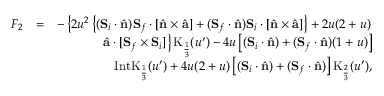<formula> <loc_0><loc_0><loc_500><loc_500>\begin{array} { r l r } { F _ { 2 } } & { = } & { - \left \{ 2 u ^ { 2 } \left \{ ( { S } _ { i } \cdot \hat { n } ) { S } _ { f } \cdot \left [ \hat { n } \times \hat { a } \right ] + ( { S } _ { f } \cdot \hat { n } ) { S } _ { i } \cdot \left [ \hat { n } \times \hat { a } \right ] \right \} + 2 u ( 2 + u ) } \\ & { \hat { a } \cdot [ { S } _ { f } \times { S } _ { i } ] \right \} K _ { \frac { 1 } { 3 } } ( u ^ { \prime } ) - 4 u \left [ ( { S } _ { i } \cdot \hat { n } ) + ( { S } _ { f } \cdot \hat { n } ) ( 1 + u ) \right ] } \\ & { I n t K _ { \frac { 1 } { 3 } } ( u ^ { \prime } ) + 4 u ( 2 + u ) \left [ ( { S } _ { i } \cdot \hat { n } ) + ( { S } _ { f } \cdot \hat { n } ) \right ] K _ { \frac { 2 } { 3 } } ( u ^ { \prime } ) , } \end{array}</formula> 